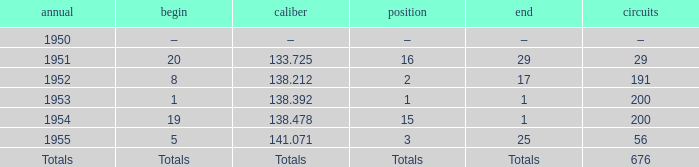What is the start of the race with 676 laps? Totals. 